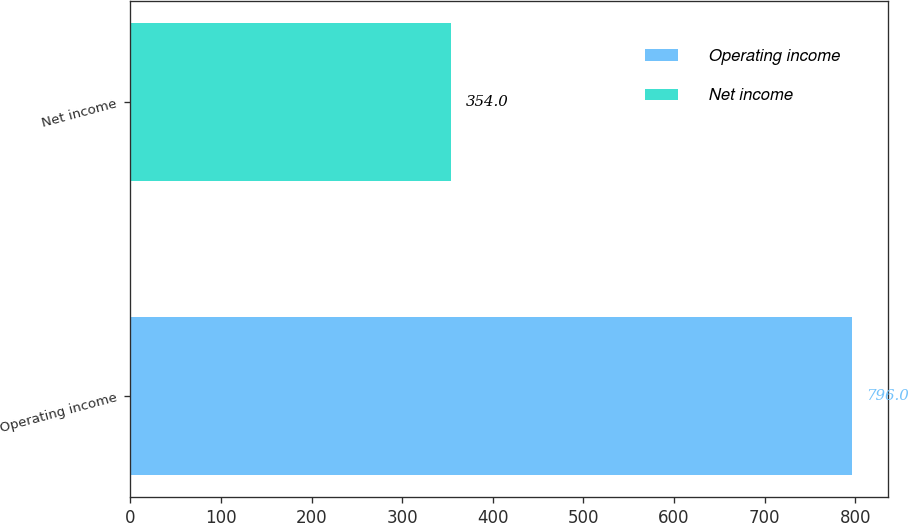Convert chart to OTSL. <chart><loc_0><loc_0><loc_500><loc_500><bar_chart><fcel>Operating income<fcel>Net income<nl><fcel>796<fcel>354<nl></chart> 